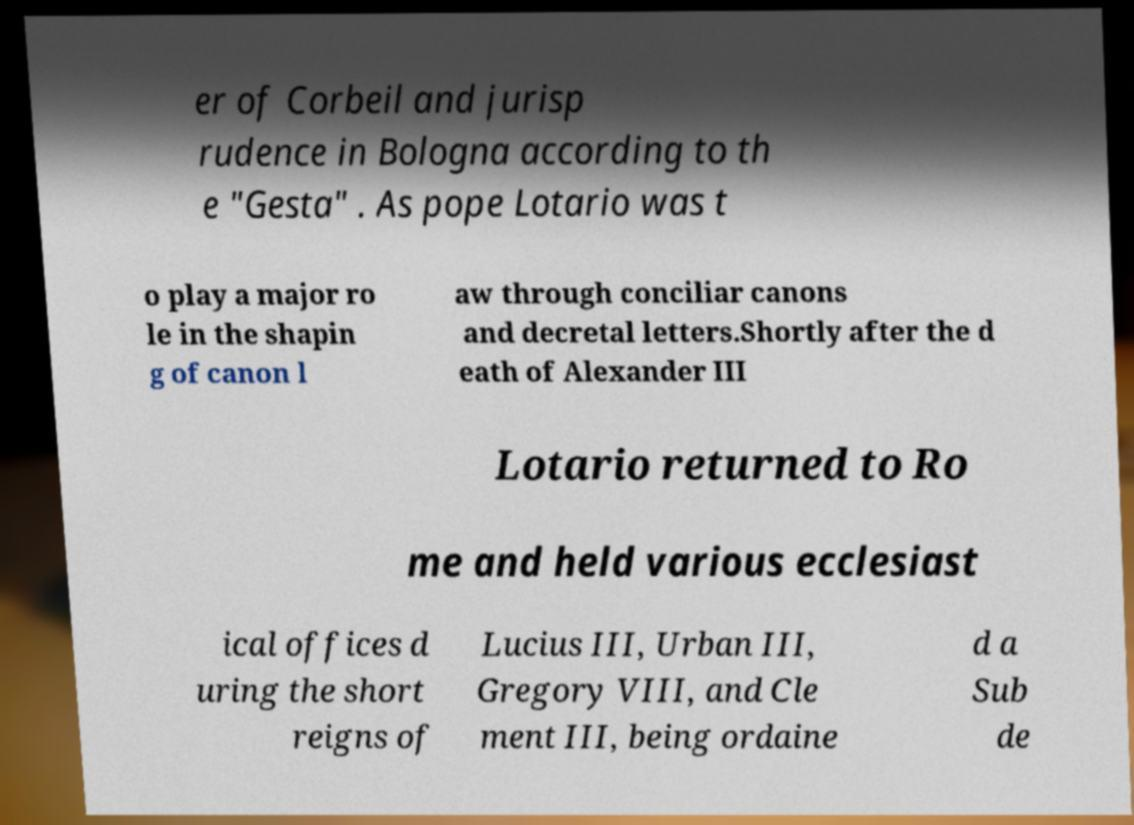What messages or text are displayed in this image? I need them in a readable, typed format. er of Corbeil and jurisp rudence in Bologna according to th e "Gesta" . As pope Lotario was t o play a major ro le in the shapin g of canon l aw through conciliar canons and decretal letters.Shortly after the d eath of Alexander III Lotario returned to Ro me and held various ecclesiast ical offices d uring the short reigns of Lucius III, Urban III, Gregory VIII, and Cle ment III, being ordaine d a Sub de 